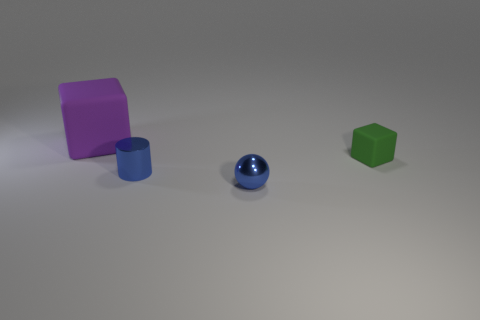What could be the possible use of these objects? The objects appear to be simplistic representations of geometric shapes, which might be used for educational purposes such as teaching geometry, colors, or spatial concepts. They could also serve as placeholders or props in a graphic design or 3D modeling project. 